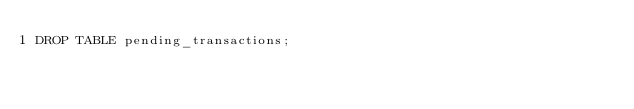Convert code to text. <code><loc_0><loc_0><loc_500><loc_500><_SQL_>DROP TABLE pending_transactions;
</code> 